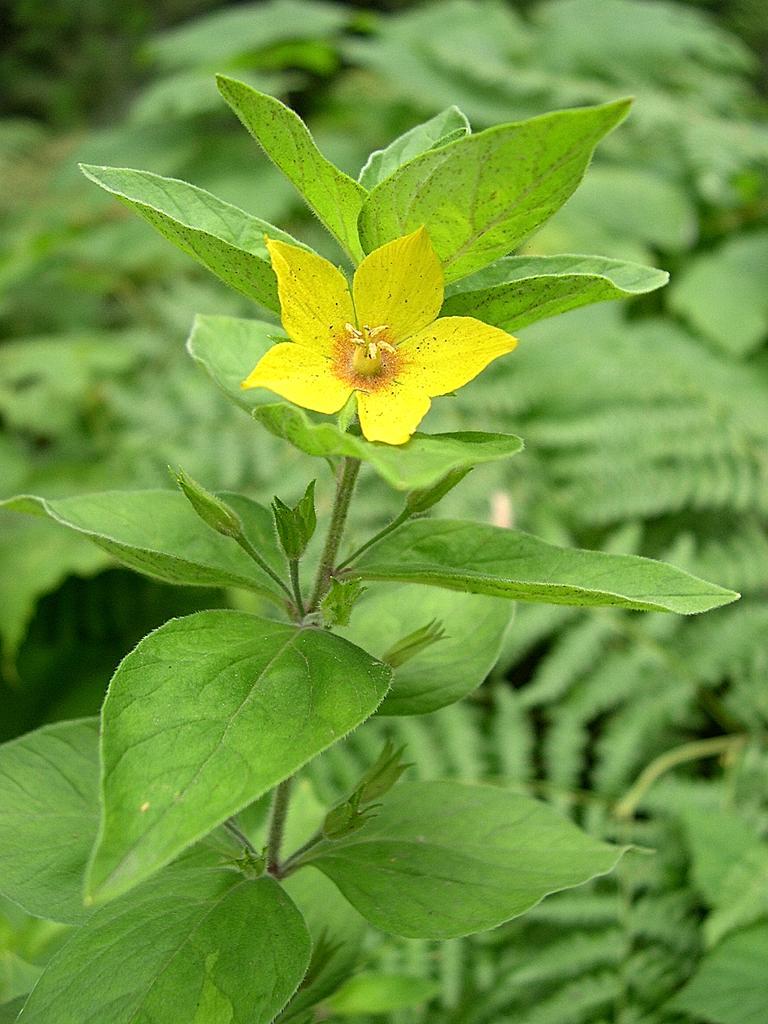Can you describe this image briefly? In this image we can see buds, flower and leaves on a stem. In the background there are leaves and it is blurry. 